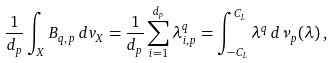Convert formula to latex. <formula><loc_0><loc_0><loc_500><loc_500>\frac { 1 } { d _ { p } } \int _ { X } B _ { q , \, p } \, d v _ { X } = \frac { 1 } { d _ { p } } \sum _ { i = 1 } ^ { d _ { p } } \lambda _ { i , p } ^ { q } = \int _ { - C _ { L } } ^ { C _ { L } } \lambda ^ { q } \, d \nu _ { p } ( \lambda ) \, ,</formula> 